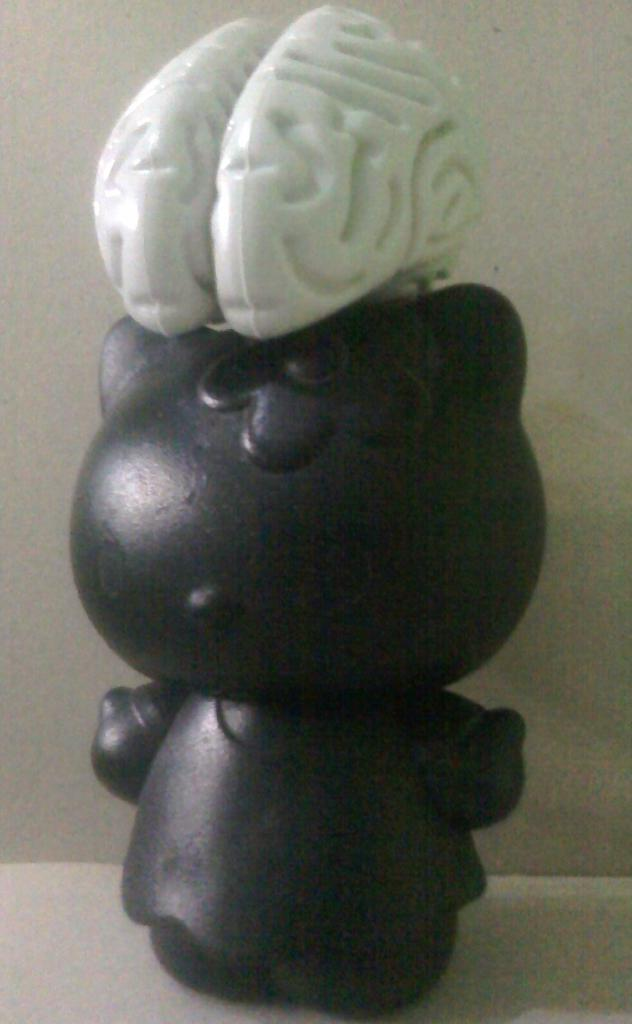What type of toy is in the image? There is a small brown-colored toy in the image. Where is the toy located in the image? The toy is in the middle of the image. What is above the toy in the image? There is a small white-colored brain above the toy. What type of apparel is the toy wearing in the image? The toy does not have any apparel in the image; it is a small brown-colored toy without any clothing. 